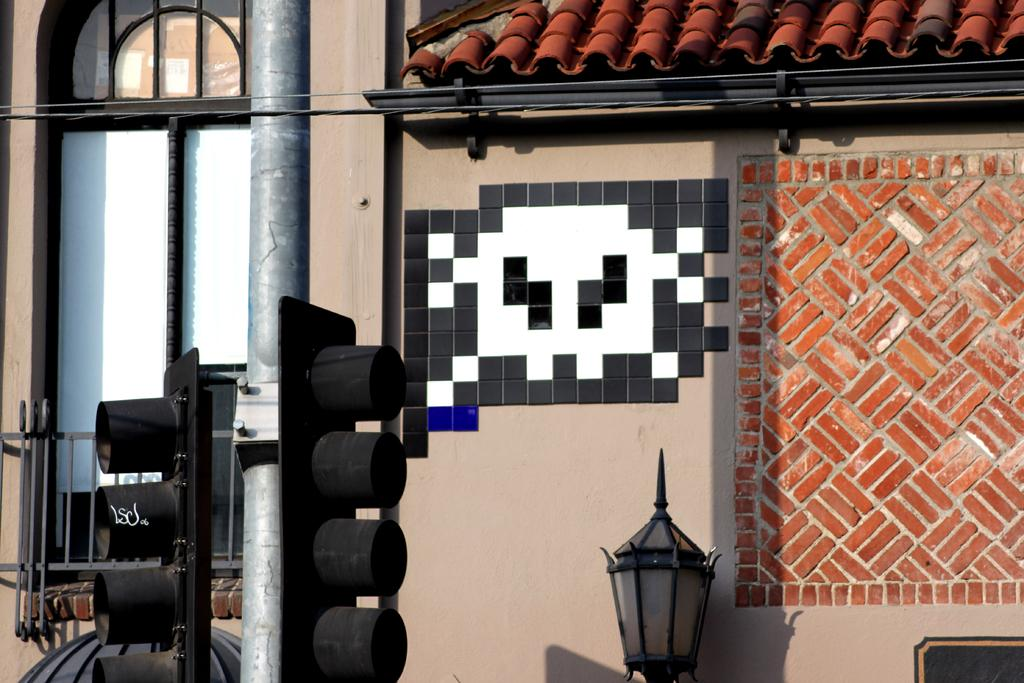Where was the image taken? The image was taken outside the city on the street. What can be seen in the foreground of the image? In the foreground, there are signal lights, a pole, and a lamp. What is located in the center of the image? There is a wall and a window in the center of the image. What is visible at the top of the image? The top of the image features a roof. How many good-byes were said during the rainstorm in the image? There is no mention of a rainstorm or any good-byes being said in the image. The image shows a street scene with signal lights, a pole, a lamp, a wall, a window, and a roof. 